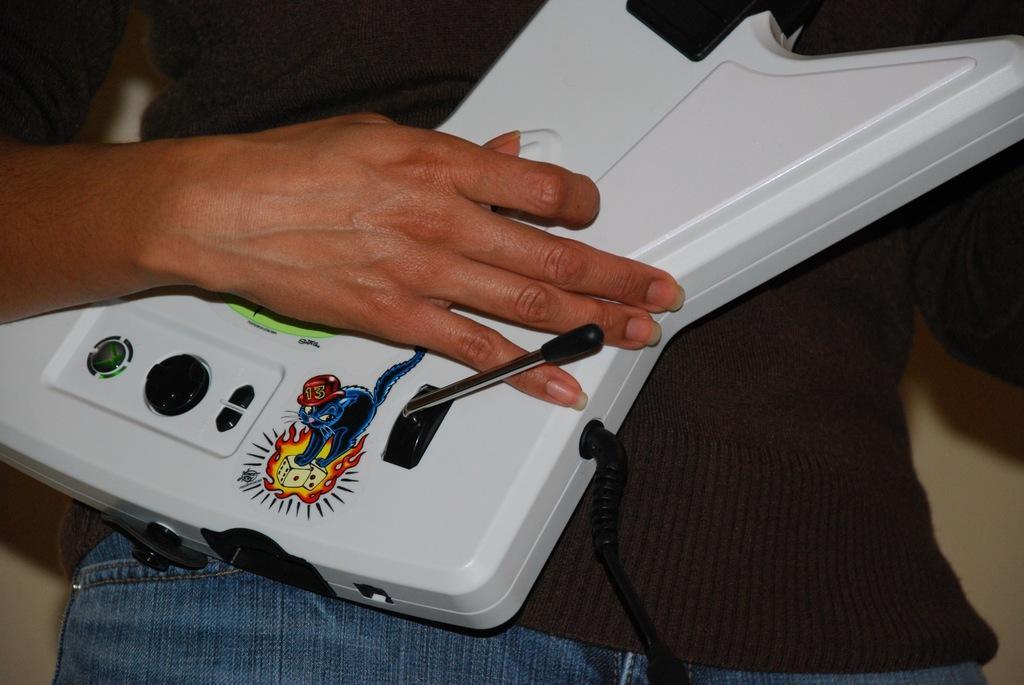In one or two sentences, can you explain what this image depicts? In this picture there is a man who is holding a white object. On the white object I can see the sticker of a cat, beside that I can see some buttons I can see the wall. 